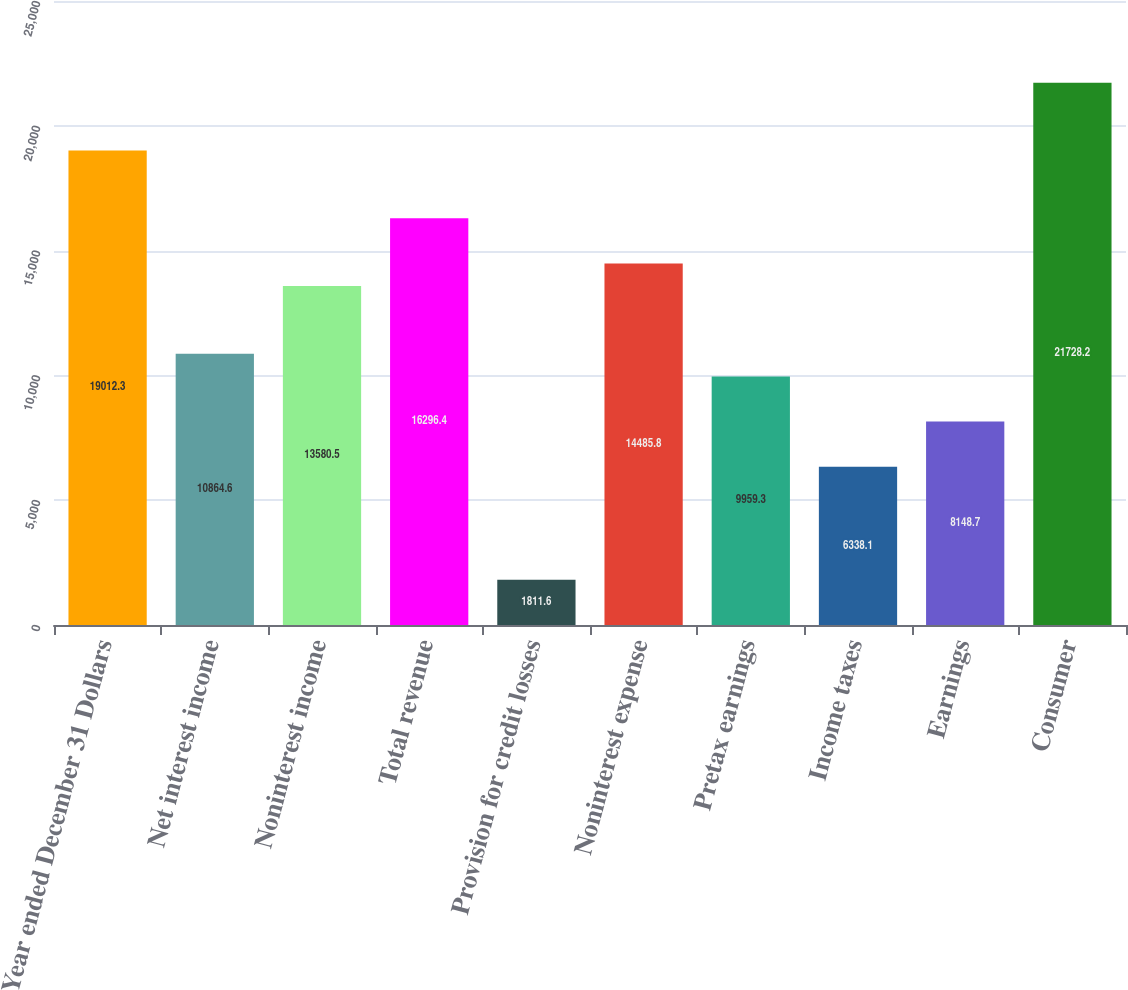<chart> <loc_0><loc_0><loc_500><loc_500><bar_chart><fcel>Year ended December 31 Dollars<fcel>Net interest income<fcel>Noninterest income<fcel>Total revenue<fcel>Provision for credit losses<fcel>Noninterest expense<fcel>Pretax earnings<fcel>Income taxes<fcel>Earnings<fcel>Consumer<nl><fcel>19012.3<fcel>10864.6<fcel>13580.5<fcel>16296.4<fcel>1811.6<fcel>14485.8<fcel>9959.3<fcel>6338.1<fcel>8148.7<fcel>21728.2<nl></chart> 